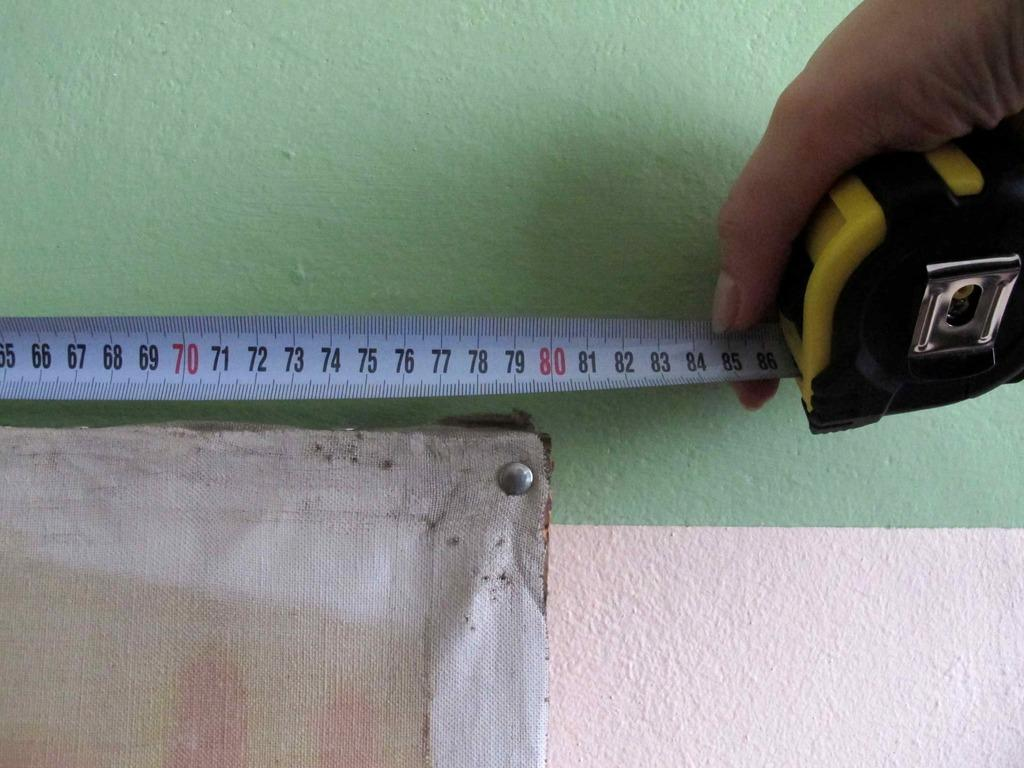<image>
Present a compact description of the photo's key features. A person measuring  a painting with a tape measure, it shows 80 inches. 